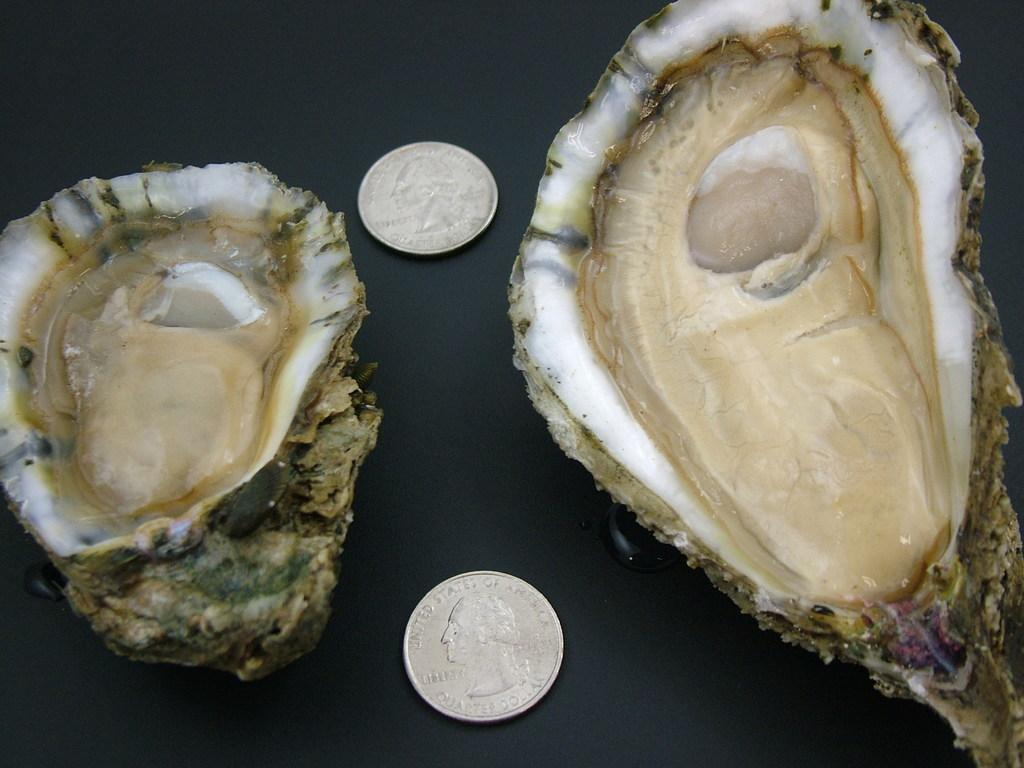What type of objects can be seen in the image? There are shells and coins in the image. Can you describe the shells in the image? The facts provided do not give specific details about the shells, but they are present in the image. What can be said about the coins in the image? Coins are present in the image. What type of camera is being used to capture the image? The facts provided do not mention a camera or any information about how the image was captured. 